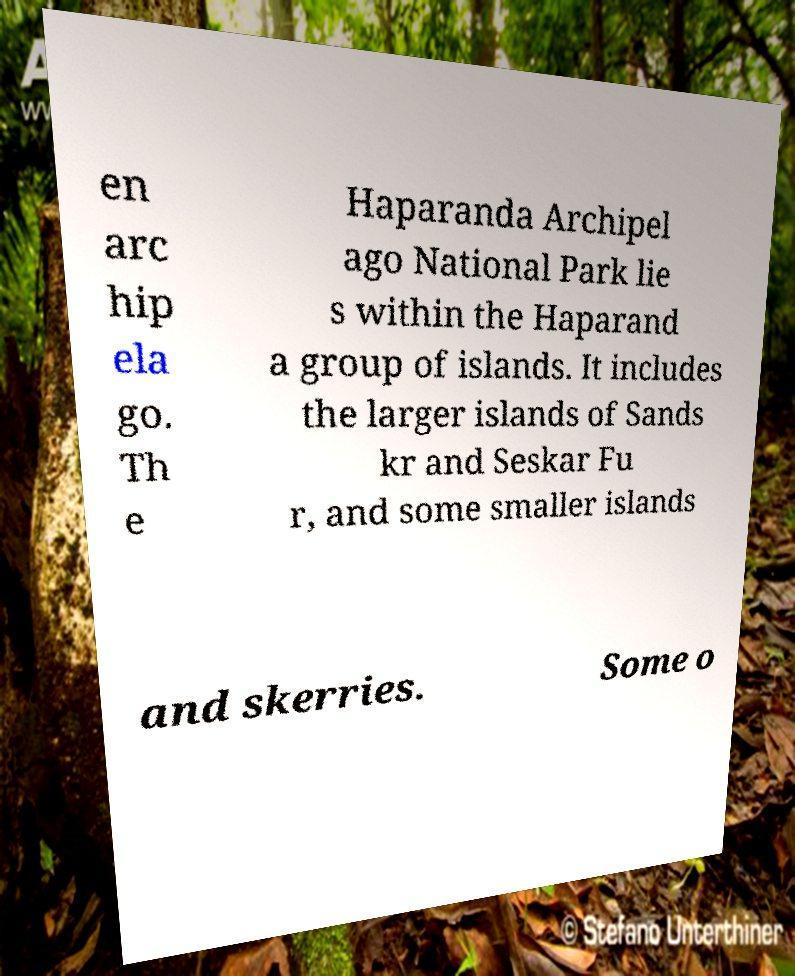Can you accurately transcribe the text from the provided image for me? en arc hip ela go. Th e Haparanda Archipel ago National Park lie s within the Haparand a group of islands. It includes the larger islands of Sands kr and Seskar Fu r, and some smaller islands and skerries. Some o 